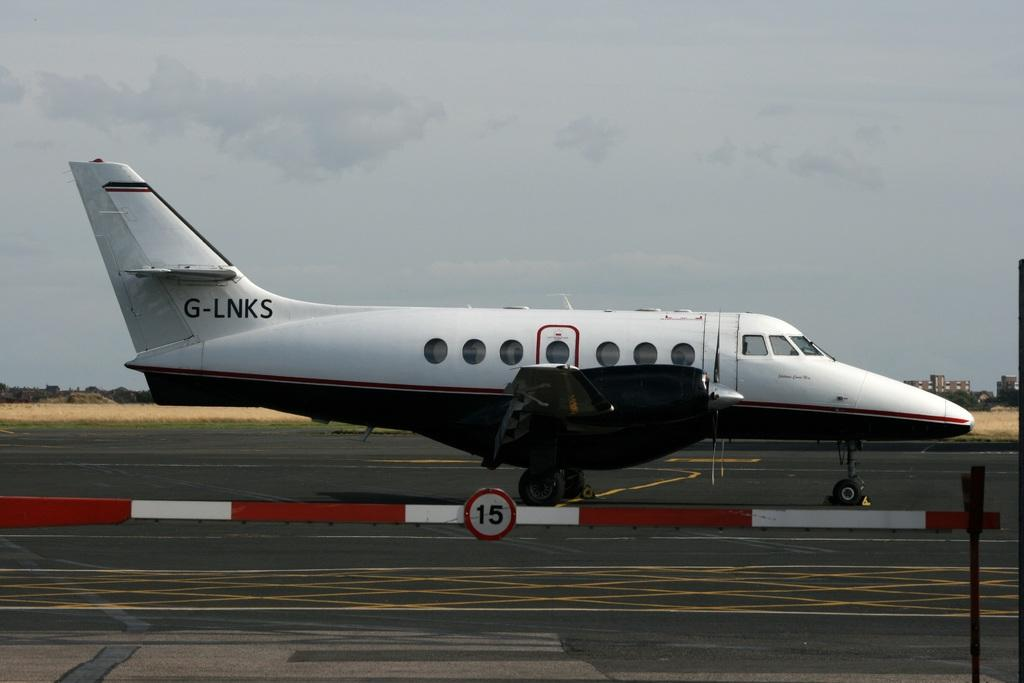What is the color of the airplane in the image? The airplane is white in the image. Where is the airplane located in the image? The airplane is on the road in the image. What can be seen in the background of the image? There are buildings, trees, and the sky visible in the background of the image. What type of waste can be seen on the airplane in the image? There is no waste present on the airplane in the image. Is there a club visible in the image? There is no club present in the image. 